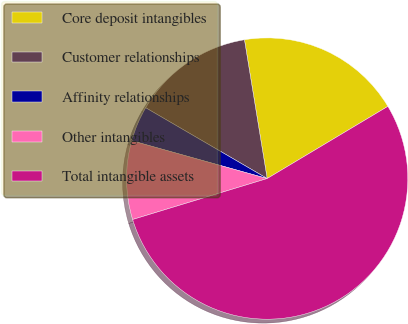Convert chart to OTSL. <chart><loc_0><loc_0><loc_500><loc_500><pie_chart><fcel>Core deposit intangibles<fcel>Customer relationships<fcel>Affinity relationships<fcel>Other intangibles<fcel>Total intangible assets<nl><fcel>19.0%<fcel>14.02%<fcel>4.06%<fcel>9.04%<fcel>53.87%<nl></chart> 